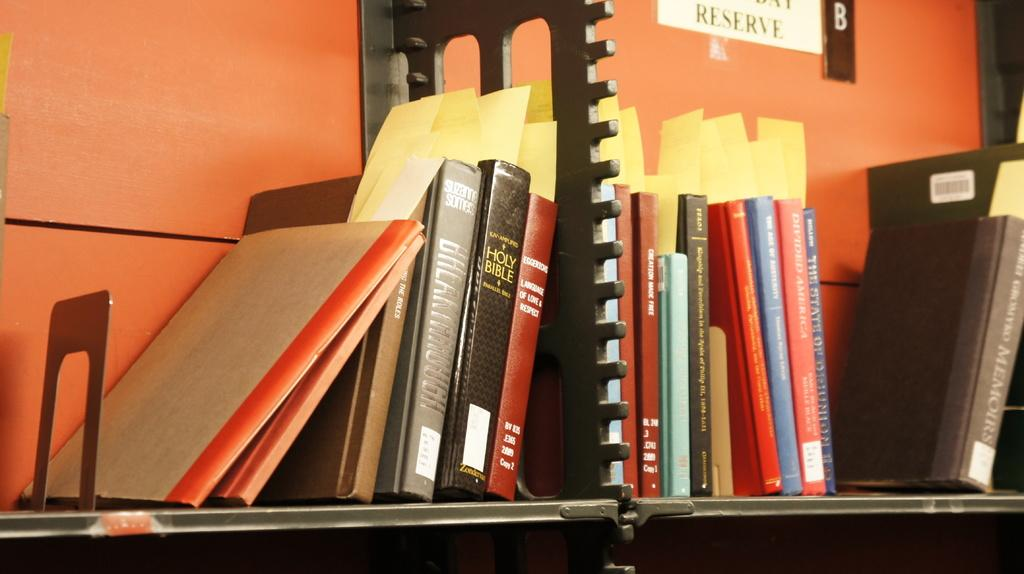<image>
Give a short and clear explanation of the subsequent image. Books on a shelf below a sign with reserve on it. 